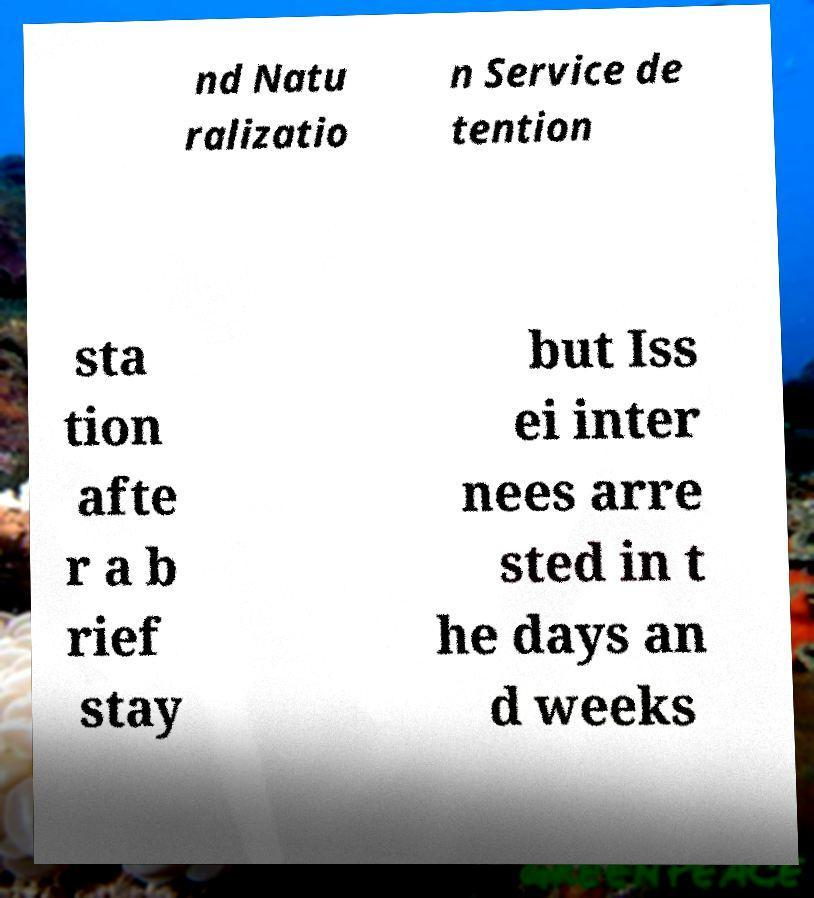For documentation purposes, I need the text within this image transcribed. Could you provide that? nd Natu ralizatio n Service de tention sta tion afte r a b rief stay but Iss ei inter nees arre sted in t he days an d weeks 